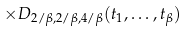<formula> <loc_0><loc_0><loc_500><loc_500>\times D _ { 2 / \beta , 2 / \beta , 4 / \beta } ( t _ { 1 } , \dots , t _ { \beta } )</formula> 